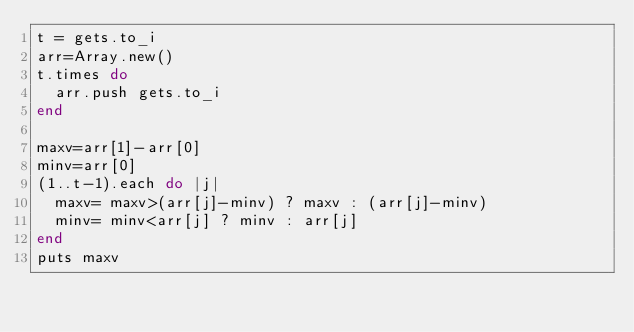<code> <loc_0><loc_0><loc_500><loc_500><_Ruby_>t = gets.to_i
arr=Array.new()
t.times do
  arr.push gets.to_i
end

maxv=arr[1]-arr[0]
minv=arr[0]
(1..t-1).each do |j|
  maxv= maxv>(arr[j]-minv) ? maxv : (arr[j]-minv)
  minv= minv<arr[j] ? minv : arr[j]
end
puts maxv</code> 